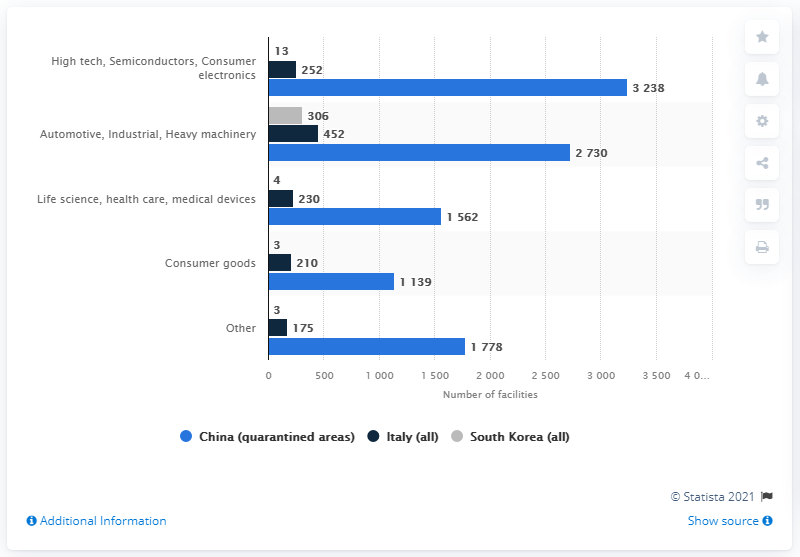Identify some key points in this picture. China, with its quarantined areas, has the least consumer goods available. It is claimed that if "Italy(all)" is used, it indicates navy blue. 